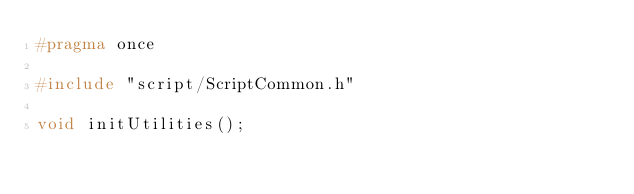Convert code to text. <code><loc_0><loc_0><loc_500><loc_500><_C_>#pragma once

#include "script/ScriptCommon.h"

void initUtilities();</code> 